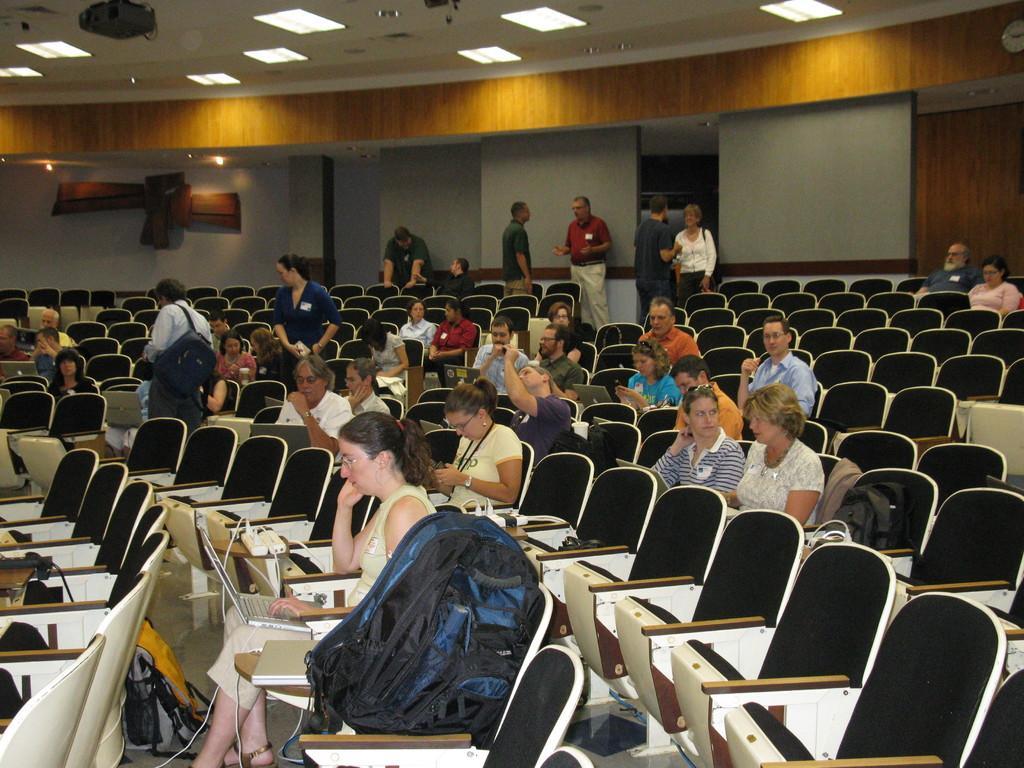Describe this image in one or two sentences. In this image I see few people sitting and few of them are standing. I can also see that there are lot of chairs and few things kept on it. In the background I see the wall and lights on the ceiling. 